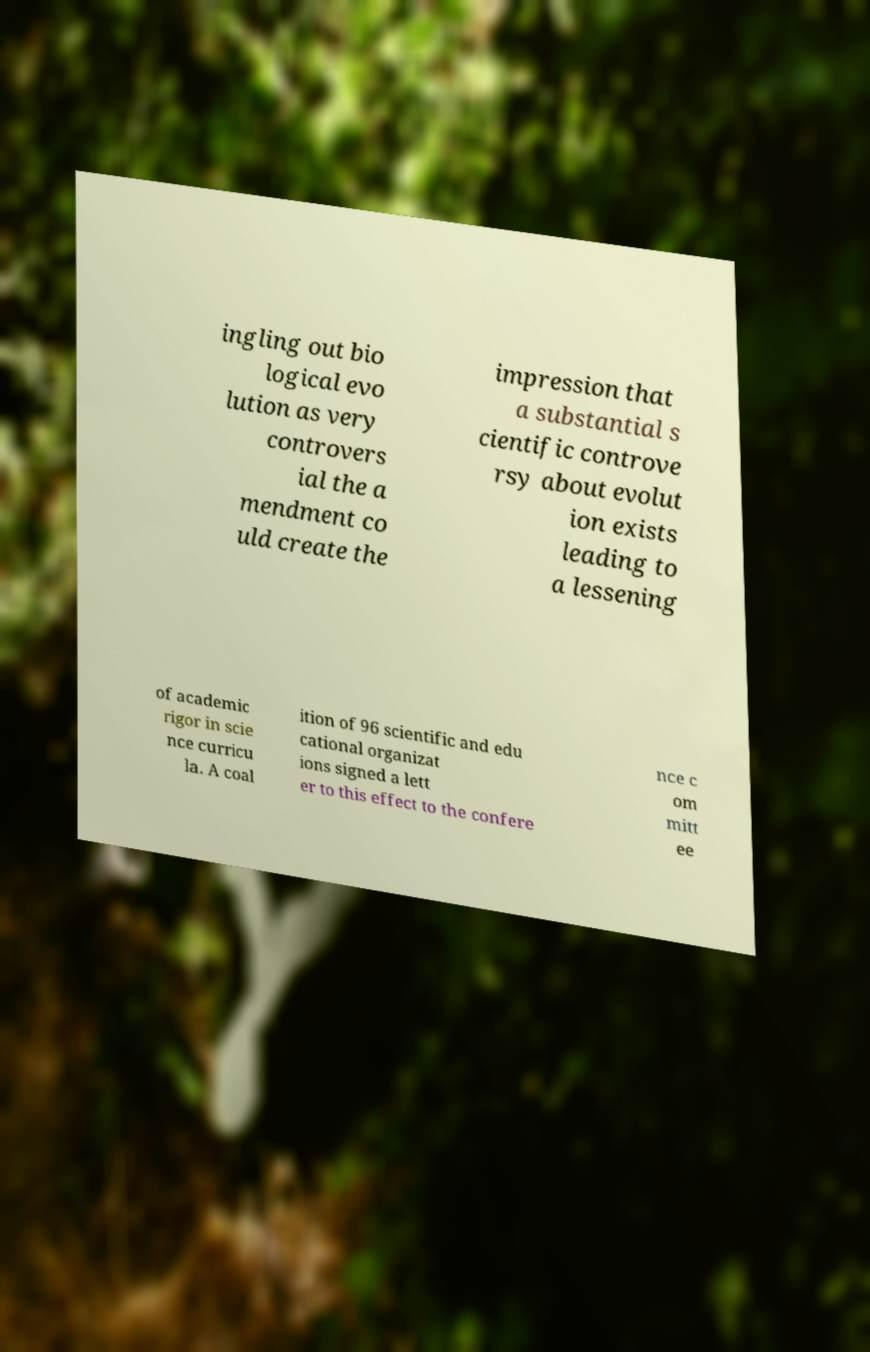Please read and relay the text visible in this image. What does it say? ingling out bio logical evo lution as very controvers ial the a mendment co uld create the impression that a substantial s cientific controve rsy about evolut ion exists leading to a lessening of academic rigor in scie nce curricu la. A coal ition of 96 scientific and edu cational organizat ions signed a lett er to this effect to the confere nce c om mitt ee 